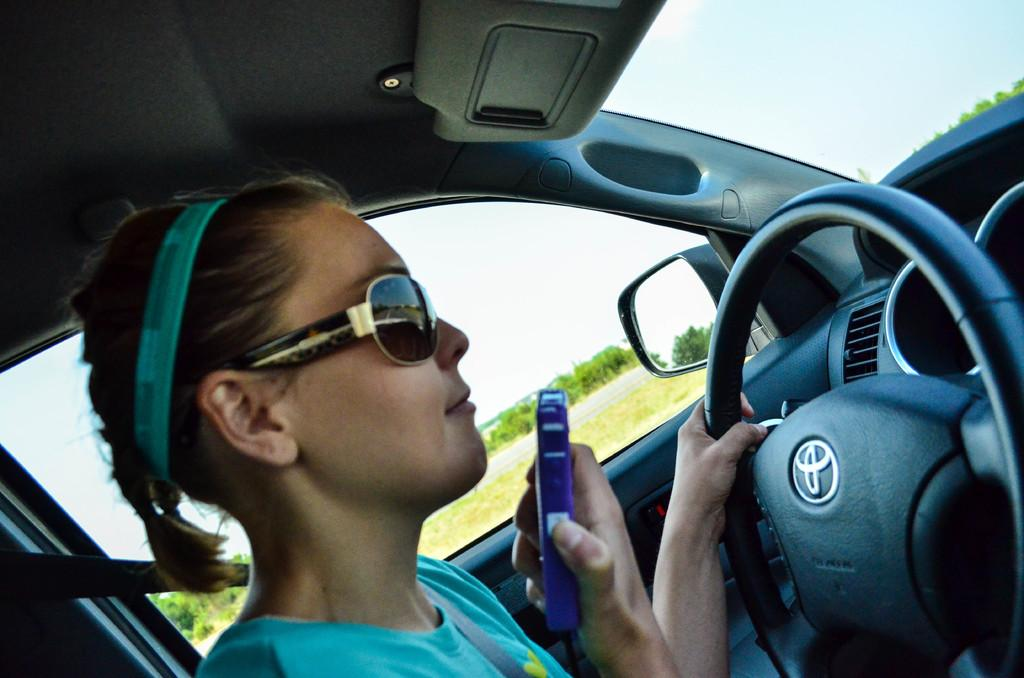What is the person inside the vehicle doing? The person is wearing goggles, which suggests they might be driving or operating the vehicle. What can be seen inside the vehicle? There is a mirror, a steering wheel, and glass in the vehicle. What is the purpose of the mirror in the vehicle? The mirror is likely used for the driver to see behind them or to adjust their appearance. What is visible through the glass in the vehicle? Trees and the sky are visible through the glass. What statement is being made by the airplane in the image? There is no airplane present in the image, so no statement can be made by an airplane. How does the brain of the person inside the vehicle function while driving? The image does not provide any information about the person's brain function, so it cannot be determined from the image. 